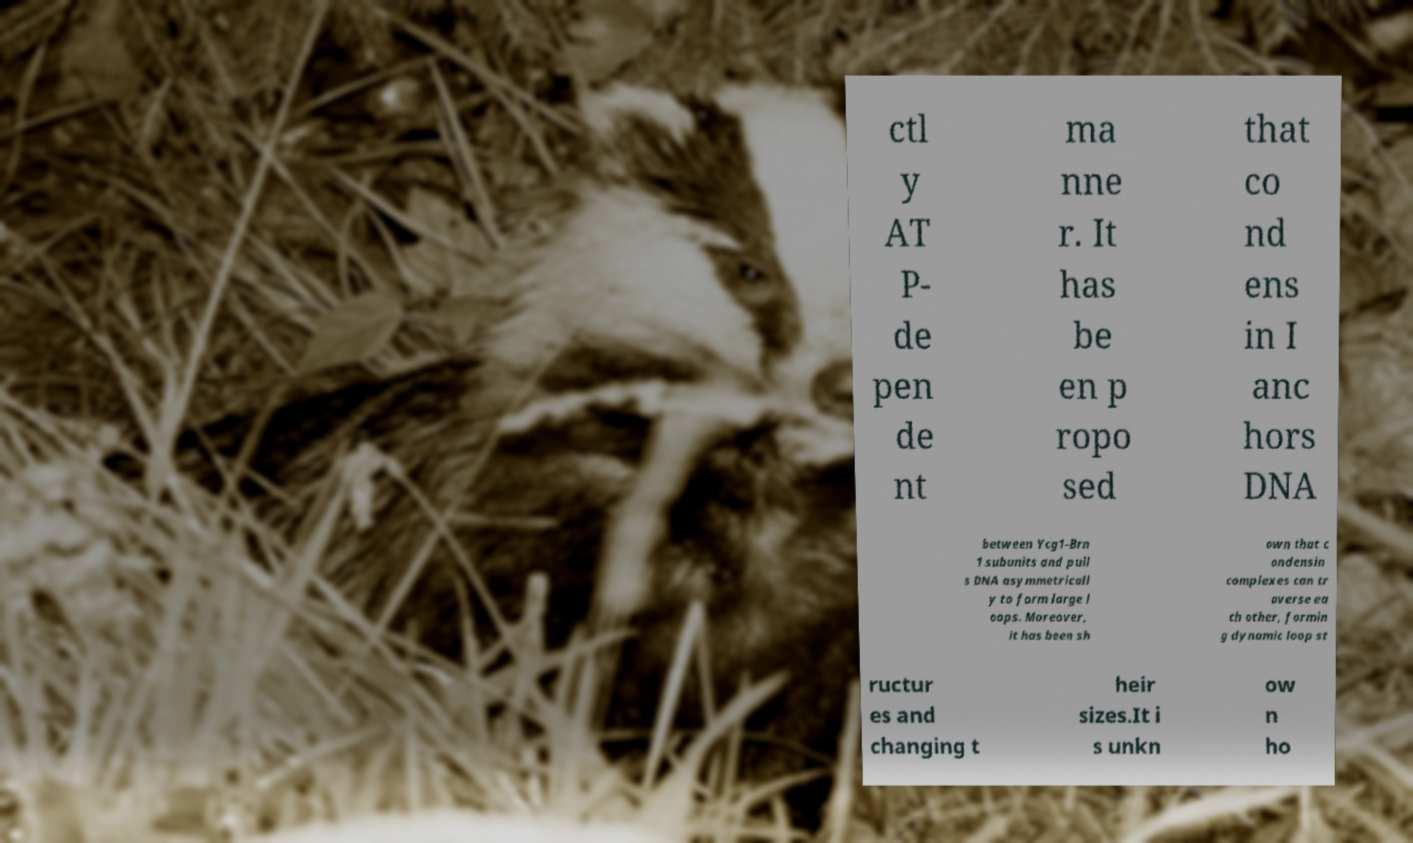Please read and relay the text visible in this image. What does it say? ctl y AT P- de pen de nt ma nne r. It has be en p ropo sed that co nd ens in I anc hors DNA between Ycg1-Brn 1 subunits and pull s DNA asymmetricall y to form large l oops. Moreover, it has been sh own that c ondensin complexes can tr averse ea ch other, formin g dynamic loop st ructur es and changing t heir sizes.It i s unkn ow n ho 